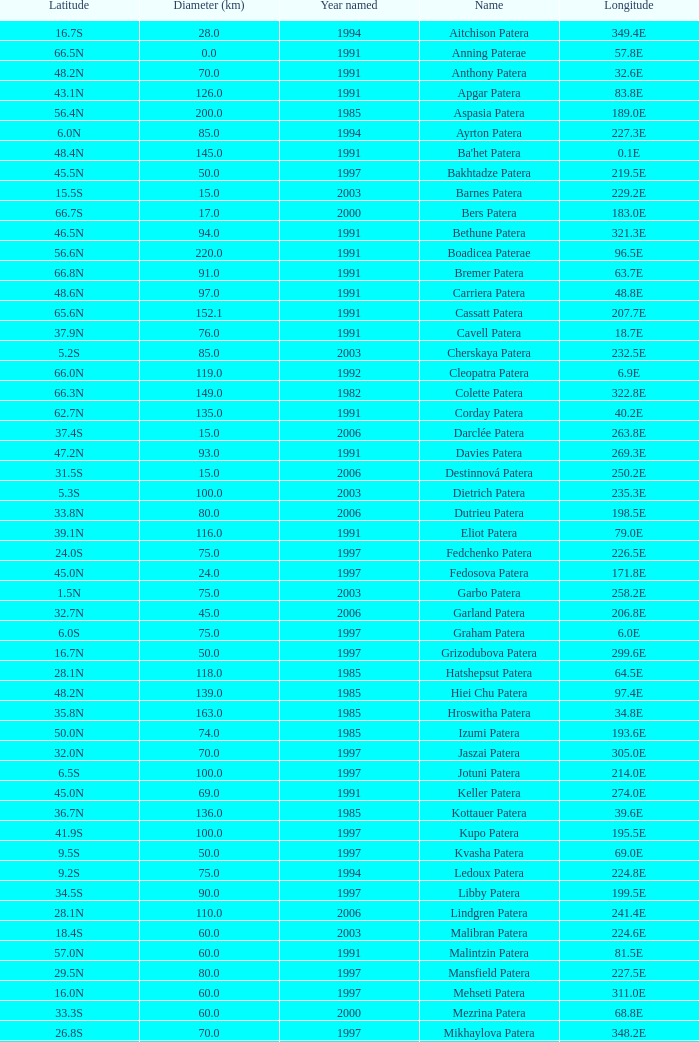What is the average Year Named, when Latitude is 37.9N, and when Diameter (km) is greater than 76? None. Would you mind parsing the complete table? {'header': ['Latitude', 'Diameter (km)', 'Year named', 'Name', 'Longitude'], 'rows': [['16.7S', '28.0', '1994', 'Aitchison Patera', '349.4E'], ['66.5N', '0.0', '1991', 'Anning Paterae', '57.8E'], ['48.2N', '70.0', '1991', 'Anthony Patera', '32.6E'], ['43.1N', '126.0', '1991', 'Apgar Patera', '83.8E'], ['56.4N', '200.0', '1985', 'Aspasia Patera', '189.0E'], ['6.0N', '85.0', '1994', 'Ayrton Patera', '227.3E'], ['48.4N', '145.0', '1991', "Ba'het Patera", '0.1E'], ['45.5N', '50.0', '1997', 'Bakhtadze Patera', '219.5E'], ['15.5S', '15.0', '2003', 'Barnes Patera', '229.2E'], ['66.7S', '17.0', '2000', 'Bers Patera', '183.0E'], ['46.5N', '94.0', '1991', 'Bethune Patera', '321.3E'], ['56.6N', '220.0', '1991', 'Boadicea Paterae', '96.5E'], ['66.8N', '91.0', '1991', 'Bremer Patera', '63.7E'], ['48.6N', '97.0', '1991', 'Carriera Patera', '48.8E'], ['65.6N', '152.1', '1991', 'Cassatt Patera', '207.7E'], ['37.9N', '76.0', '1991', 'Cavell Patera', '18.7E'], ['5.2S', '85.0', '2003', 'Cherskaya Patera', '232.5E'], ['66.0N', '119.0', '1992', 'Cleopatra Patera', '6.9E'], ['66.3N', '149.0', '1982', 'Colette Patera', '322.8E'], ['62.7N', '135.0', '1991', 'Corday Patera', '40.2E'], ['37.4S', '15.0', '2006', 'Darclée Patera', '263.8E'], ['47.2N', '93.0', '1991', 'Davies Patera', '269.3E'], ['31.5S', '15.0', '2006', 'Destinnová Patera', '250.2E'], ['5.3S', '100.0', '2003', 'Dietrich Patera', '235.3E'], ['33.8N', '80.0', '2006', 'Dutrieu Patera', '198.5E'], ['39.1N', '116.0', '1991', 'Eliot Patera', '79.0E'], ['24.0S', '75.0', '1997', 'Fedchenko Patera', '226.5E'], ['45.0N', '24.0', '1997', 'Fedosova Patera', '171.8E'], ['1.5N', '75.0', '2003', 'Garbo Patera', '258.2E'], ['32.7N', '45.0', '2006', 'Garland Patera', '206.8E'], ['6.0S', '75.0', '1997', 'Graham Patera', '6.0E'], ['16.7N', '50.0', '1997', 'Grizodubova Patera', '299.6E'], ['28.1N', '118.0', '1985', 'Hatshepsut Patera', '64.5E'], ['48.2N', '139.0', '1985', 'Hiei Chu Patera', '97.4E'], ['35.8N', '163.0', '1985', 'Hroswitha Patera', '34.8E'], ['50.0N', '74.0', '1985', 'Izumi Patera', '193.6E'], ['32.0N', '70.0', '1997', 'Jaszai Patera', '305.0E'], ['6.5S', '100.0', '1997', 'Jotuni Patera', '214.0E'], ['45.0N', '69.0', '1991', 'Keller Patera', '274.0E'], ['36.7N', '136.0', '1985', 'Kottauer Patera', '39.6E'], ['41.9S', '100.0', '1997', 'Kupo Patera', '195.5E'], ['9.5S', '50.0', '1997', 'Kvasha Patera', '69.0E'], ['9.2S', '75.0', '1994', 'Ledoux Patera', '224.8E'], ['34.5S', '90.0', '1997', 'Libby Patera', '199.5E'], ['28.1N', '110.0', '2006', 'Lindgren Patera', '241.4E'], ['18.4S', '60.0', '2003', 'Malibran Patera', '224.6E'], ['57.0N', '60.0', '1991', 'Malintzin Patera', '81.5E'], ['29.5N', '80.0', '1997', 'Mansfield Patera', '227.5E'], ['16.0N', '60.0', '1997', 'Mehseti Patera', '311.0E'], ['33.3S', '60.0', '2000', 'Mezrina Patera', '68.8E'], ['26.8S', '70.0', '1997', 'Mikhaylova Patera', '348.2E'], ['33.9N', '100.0', '2006', 'Nikolaeva Patera', '267.5E'], ['35.0S', '140.0', '1997', 'Nordenflycht Patera', '266.0E'], ['68.7N', '85.5', '1991', 'Nzingha Patera', '205.7E'], ['13.0S', '50.0', '1997', 'Panina Patera', '309.8E'], ['25.5S', '100.0', '1997', 'Payne-Gaposchkin Patera', '196.0E'], ['26.5N', '100.0', '1997', 'Pchilka Patera', '234.0E'], ['64.9N', '78.0', '1991', 'Pocahontas Patera', '49.4E'], ['51.0S', '80.0', '1994', 'Raskova Paterae', '222.8E'], ['46.2N', '157.0', '1985', 'Razia Patera', '197.8E'], ['2.8S', '120.0', '2003', 'Rogneda Patera', '220.5E'], ['64.3N', '233.0', '1982', 'Sacajawea Patera', '335.4E'], ['49.1N', '65.0', '1991', 'Sachs Patera', '334.2E'], ['41.7N', '181.0', '1991', 'Sand Patera', '15.5E'], ['14.1N', '225.0', '1979', 'Sappho Patera', '16.5E'], ['74.3N', '121.7', '1991', 'Schumann-Heink Patera', '214.5E'], ['20.0N', '60.0', '1997', 'Serova Patera', '247.0E'], ['75.7S', '60.0', '1997', 'Shelikhova Patera', '162.5E'], ['6.5N', '60.0', '1997', 'Shulzhenko Patera', '264.5E'], ['61.6N', '47.0', '1997', 'Siddons Patera', '340.6E'], ['42.6N', '169.0', '1991', 'Stopes Patera', '46.5E'], ['58.2S', '80.0', '1994', 'Tarbell Patera', '351.5E'], ['67.6S', '75.0', '1994', 'Teasdale Patera', '189.1E'], ['1.4S', '80.0', '2000', 'Tenisheva Patera', '254.8E'], ['17.8S', '20.0', '1994', 'Tey Patera', '349.1E'], ['23.0N', '0.0', '1982', 'Theodora Patera', '280.0E'], ['38.9N', '99.0', '1985', 'Tipporah Patera', '43.0E'], ['42.4N', '163.0', '1991', 'Tituba Patera', '214.7E'], ['41.3N', '146.0', '1985', 'Trotula Patera', '18.9E'], ['7.0S', '55.0', '2000', 'Viardot Patera', '254.3E'], ['11.6S', '45.0', '2003', 'Vibert-Douglas Patera', '194.3E'], ['22.0S', '100.0', '1997', 'Villepreux-Power Patera', '210.0E'], ['38.0S', '80.0', '1997', 'Vovchok Patera', '310.0E'], ['21.3S', '75.0', '2000', 'Wilde Patera', '266.3E'], ['25.8S', '35.0', '2006', 'Witte Patera', '247.65E'], ['37.4N', '83.0', '1991', 'Woodhull Patera', '305.4E'], ['38.8N', '112.0', '1985', 'Yaroslavna Patera', '21.2E'], ['35.0S', '60.0', '1997', 'Žemaite Patera', '263.0E']]} 